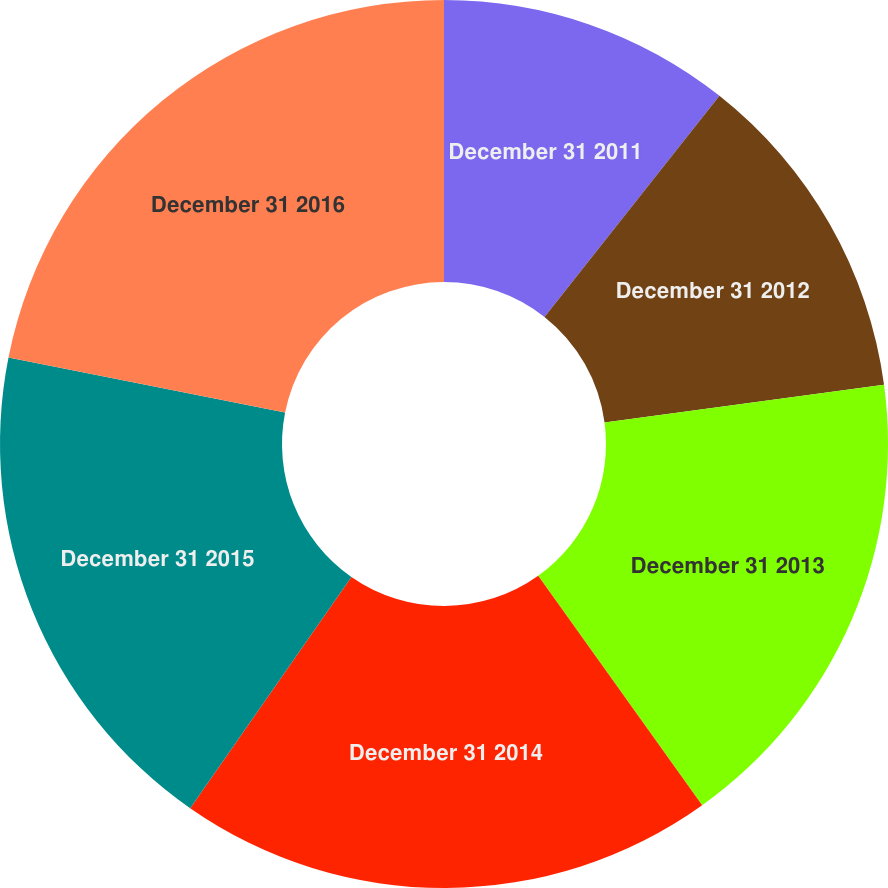Convert chart. <chart><loc_0><loc_0><loc_500><loc_500><pie_chart><fcel>December 31 2011<fcel>December 31 2012<fcel>December 31 2013<fcel>December 31 2014<fcel>December 31 2015<fcel>December 31 2016<nl><fcel>10.65%<fcel>12.22%<fcel>17.25%<fcel>19.56%<fcel>18.43%<fcel>21.88%<nl></chart> 